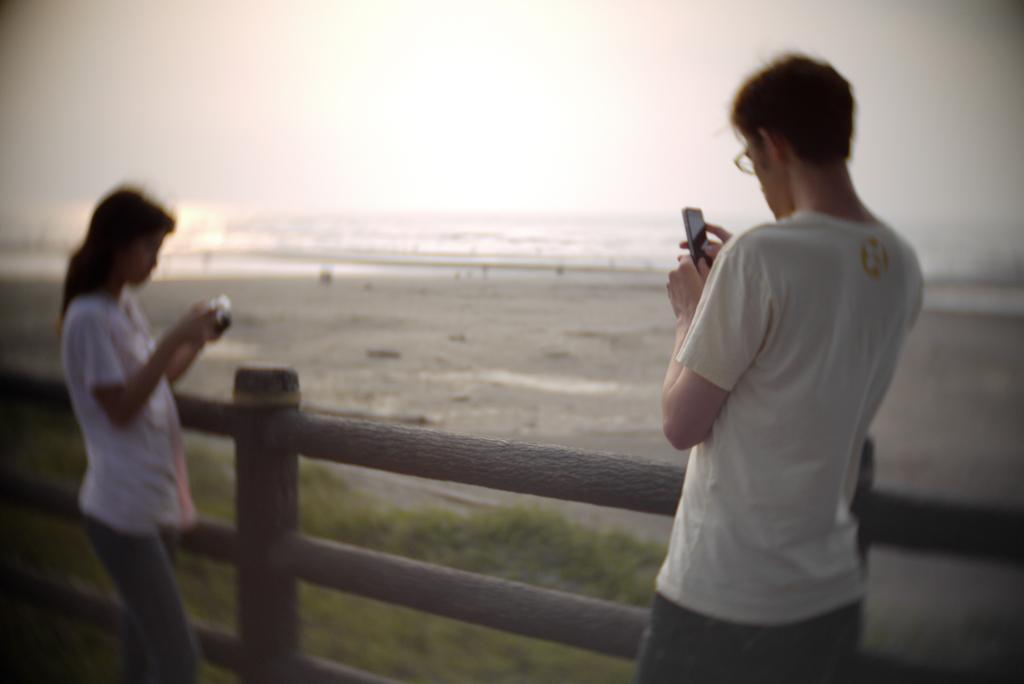Please provide a concise description of this image. On the right side, we see a man in the white T-shirt is standing and he is holding a mobile phone in his hands. Beside him, we see the wooden fence. On the left side, we see a woman in the white T-shirt is standing and she is holding an object in her hands. At the bottom, we see the grass. In the background, we see water and this water might be in the river. At the top, we see the sky and the sun. 